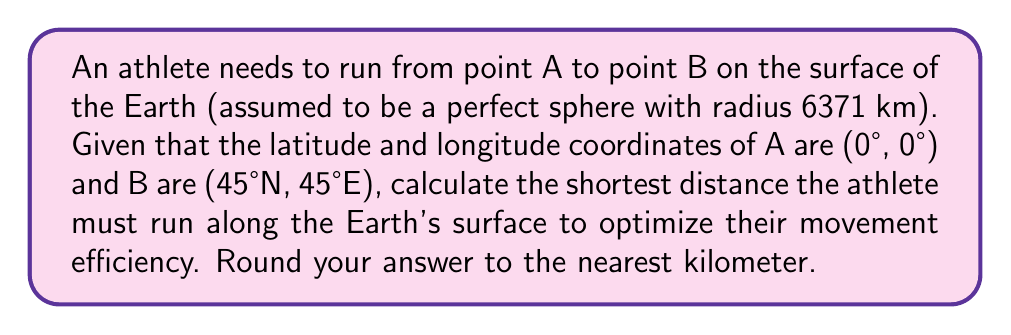Give your solution to this math problem. To solve this problem, we need to use the concept of great circles in spherical geometry. The shortest path between two points on a sphere is along the great circle that passes through both points. We can calculate this distance using the great circle distance formula:

1) First, we need to convert the latitude and longitude to radians:
   A: (0°, 0°) = (0, 0) radians
   B: (45°N, 45°E) = ($\frac{\pi}{4}$, $\frac{\pi}{4}$) radians

2) The great circle distance formula is:
   $$d = r \cdot \arccos(\sin(\phi_1)\sin(\phi_2) + \cos(\phi_1)\cos(\phi_2)\cos(\Delta\lambda))$$
   
   Where:
   $r$ is the radius of the Earth (6371 km)
   $\phi_1$, $\phi_2$ are the latitudes of points A and B in radians
   $\Delta\lambda$ is the absolute difference in longitude in radians

3) Plugging in our values:
   $$d = 6371 \cdot \arccos(\sin(0)\sin(\frac{\pi}{4}) + \cos(0)\cos(\frac{\pi}{4})\cos(\frac{\pi}{4} - 0))$$

4) Simplify:
   $$d = 6371 \cdot \arccos(0 + \cos(\frac{\pi}{4})\cos(\frac{\pi}{4}))$$
   $$d = 6371 \cdot \arccos(\frac{1}{2})$$

5) Calculate:
   $$d = 6371 \cdot 1.0472 \approx 6671.7 \text{ km}$$

6) Rounding to the nearest kilometer:
   $$d \approx 6672 \text{ km}$$
Answer: 6672 km 